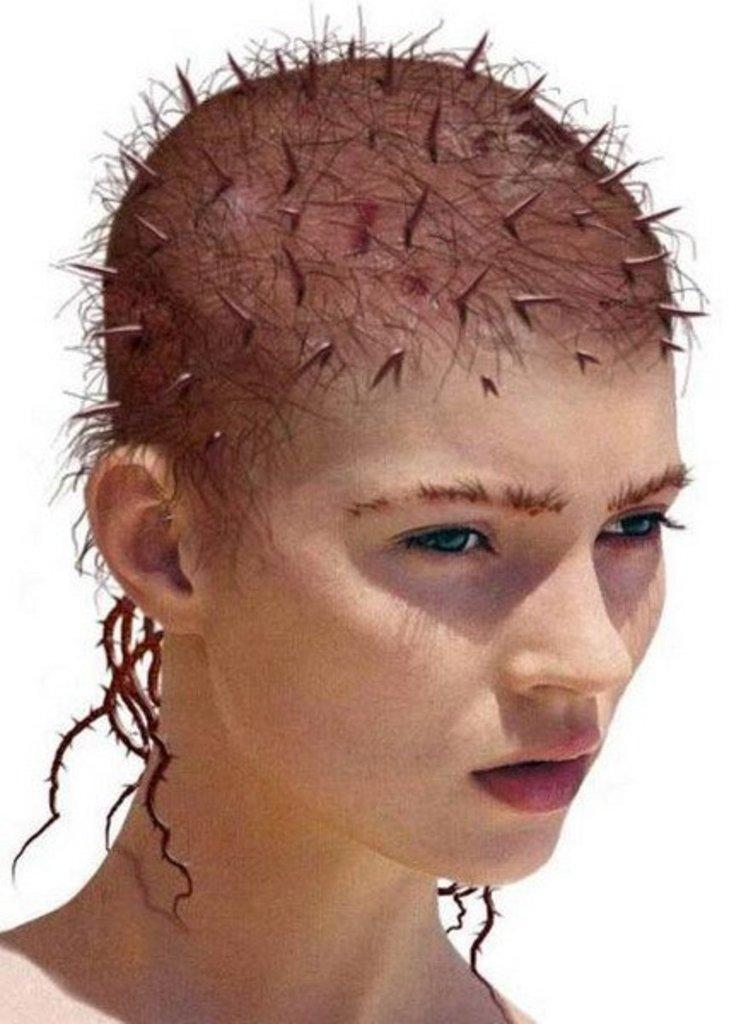Who or what is the main subject in the image? There is a person in the image. What can be observed about the background of the image? The background of the image is white. What type of soup is being served in the image? There is no soup present in the image; it only features a person and a white background. 